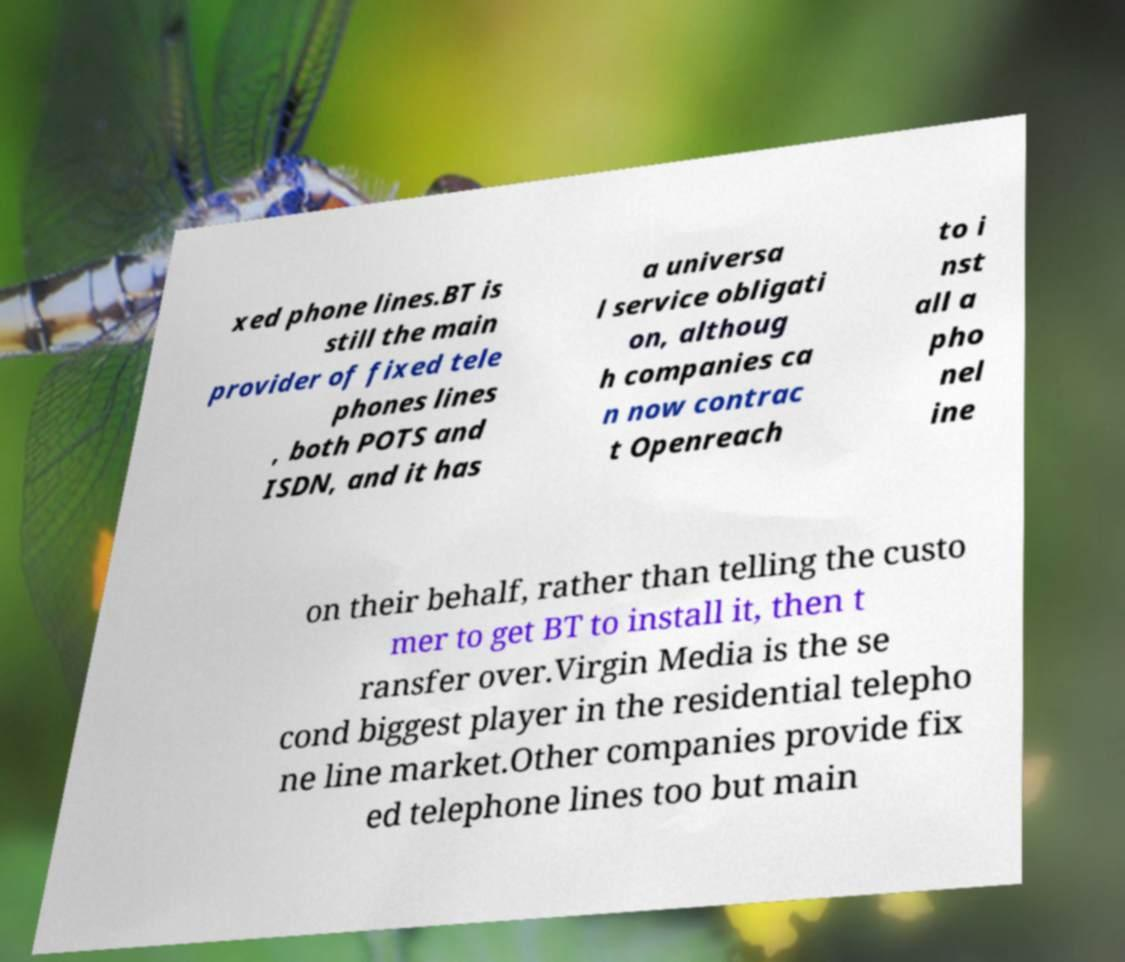What messages or text are displayed in this image? I need them in a readable, typed format. xed phone lines.BT is still the main provider of fixed tele phones lines , both POTS and ISDN, and it has a universa l service obligati on, althoug h companies ca n now contrac t Openreach to i nst all a pho nel ine on their behalf, rather than telling the custo mer to get BT to install it, then t ransfer over.Virgin Media is the se cond biggest player in the residential telepho ne line market.Other companies provide fix ed telephone lines too but main 